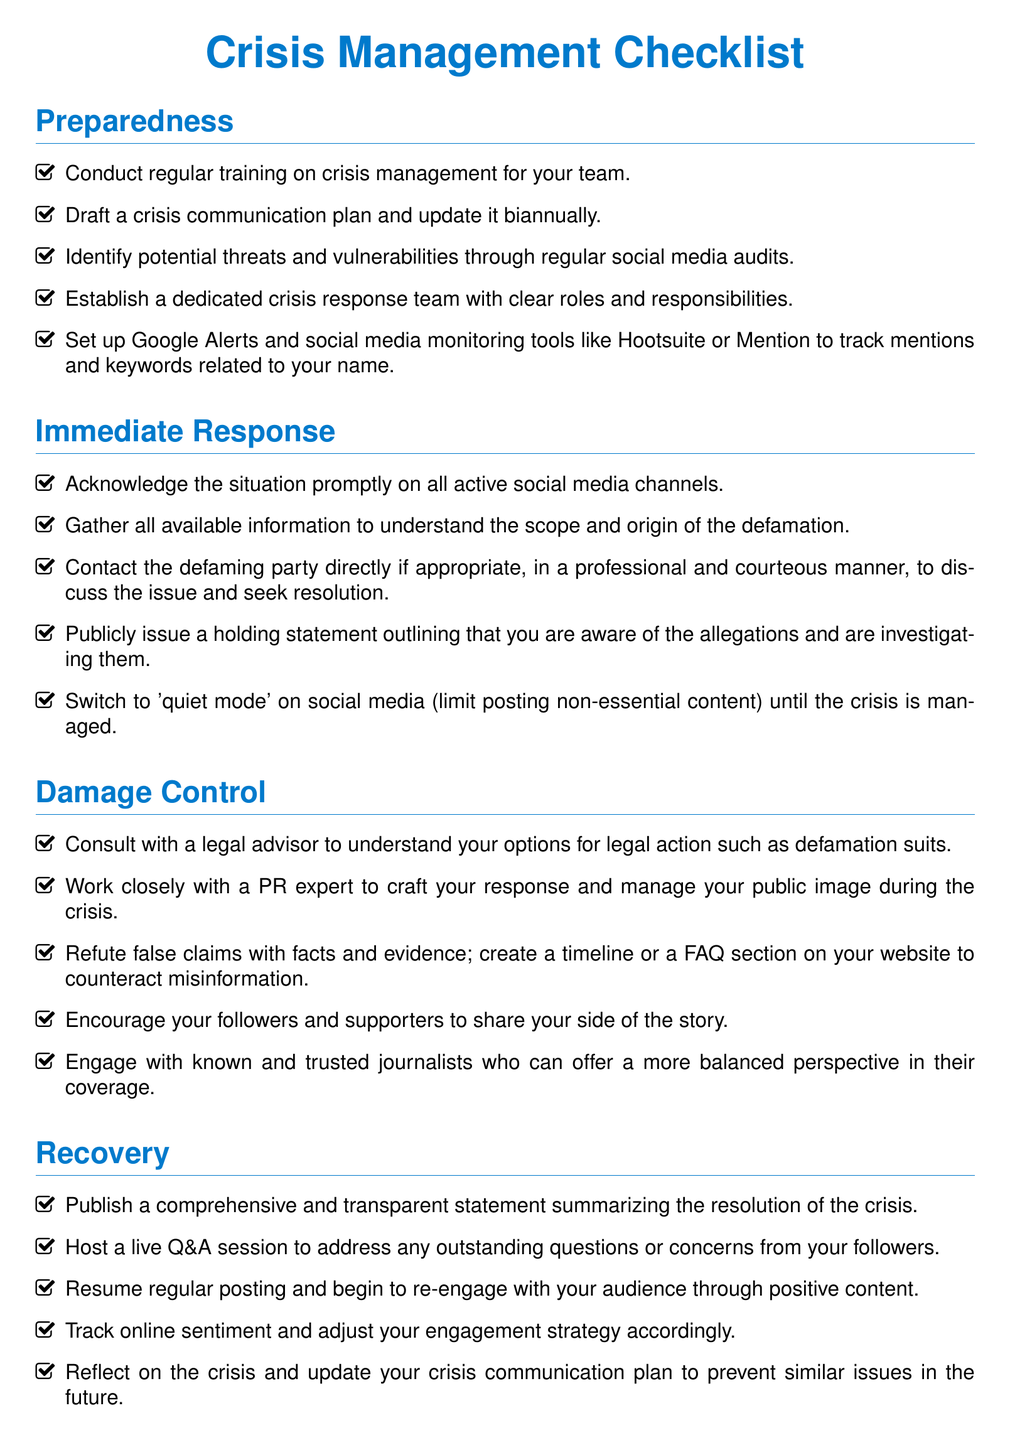What is the first item listed under Preparedness? The first item listed under Preparedness is about conducting regular training on crisis management for your team.
Answer: Conduct regular training on crisis management for your team How often should the crisis communication plan be updated? The crisis communication plan should be updated biannually, as stated in the document.
Answer: Biannually What should you do immediately after acknowledging the situation? After acknowledging the situation, you should gather all available information to understand the scope and origin of the defamation.
Answer: Gather all available information Which team is suggested to be established for crisis response? A dedicated crisis response team should be established with clear roles and responsibilities.
Answer: Crisis response team What is a recommended action for damage control regarding false claims? To counteract misinformation, it is recommended to refute false claims with facts and evidence.
Answer: Refute false claims with facts and evidence What is one way to build a supportive community? Regularly engaging with your audience helps build a loyal and supportive community.
Answer: Regularly engage with your audience What should be published after resolving the crisis? A comprehensive and transparent statement summarizing the resolution of the crisis should be published.
Answer: Comprehensive and transparent statement How many sections are there in the checklist document? There are five sections outlined in the checklist document.
Answer: Five 